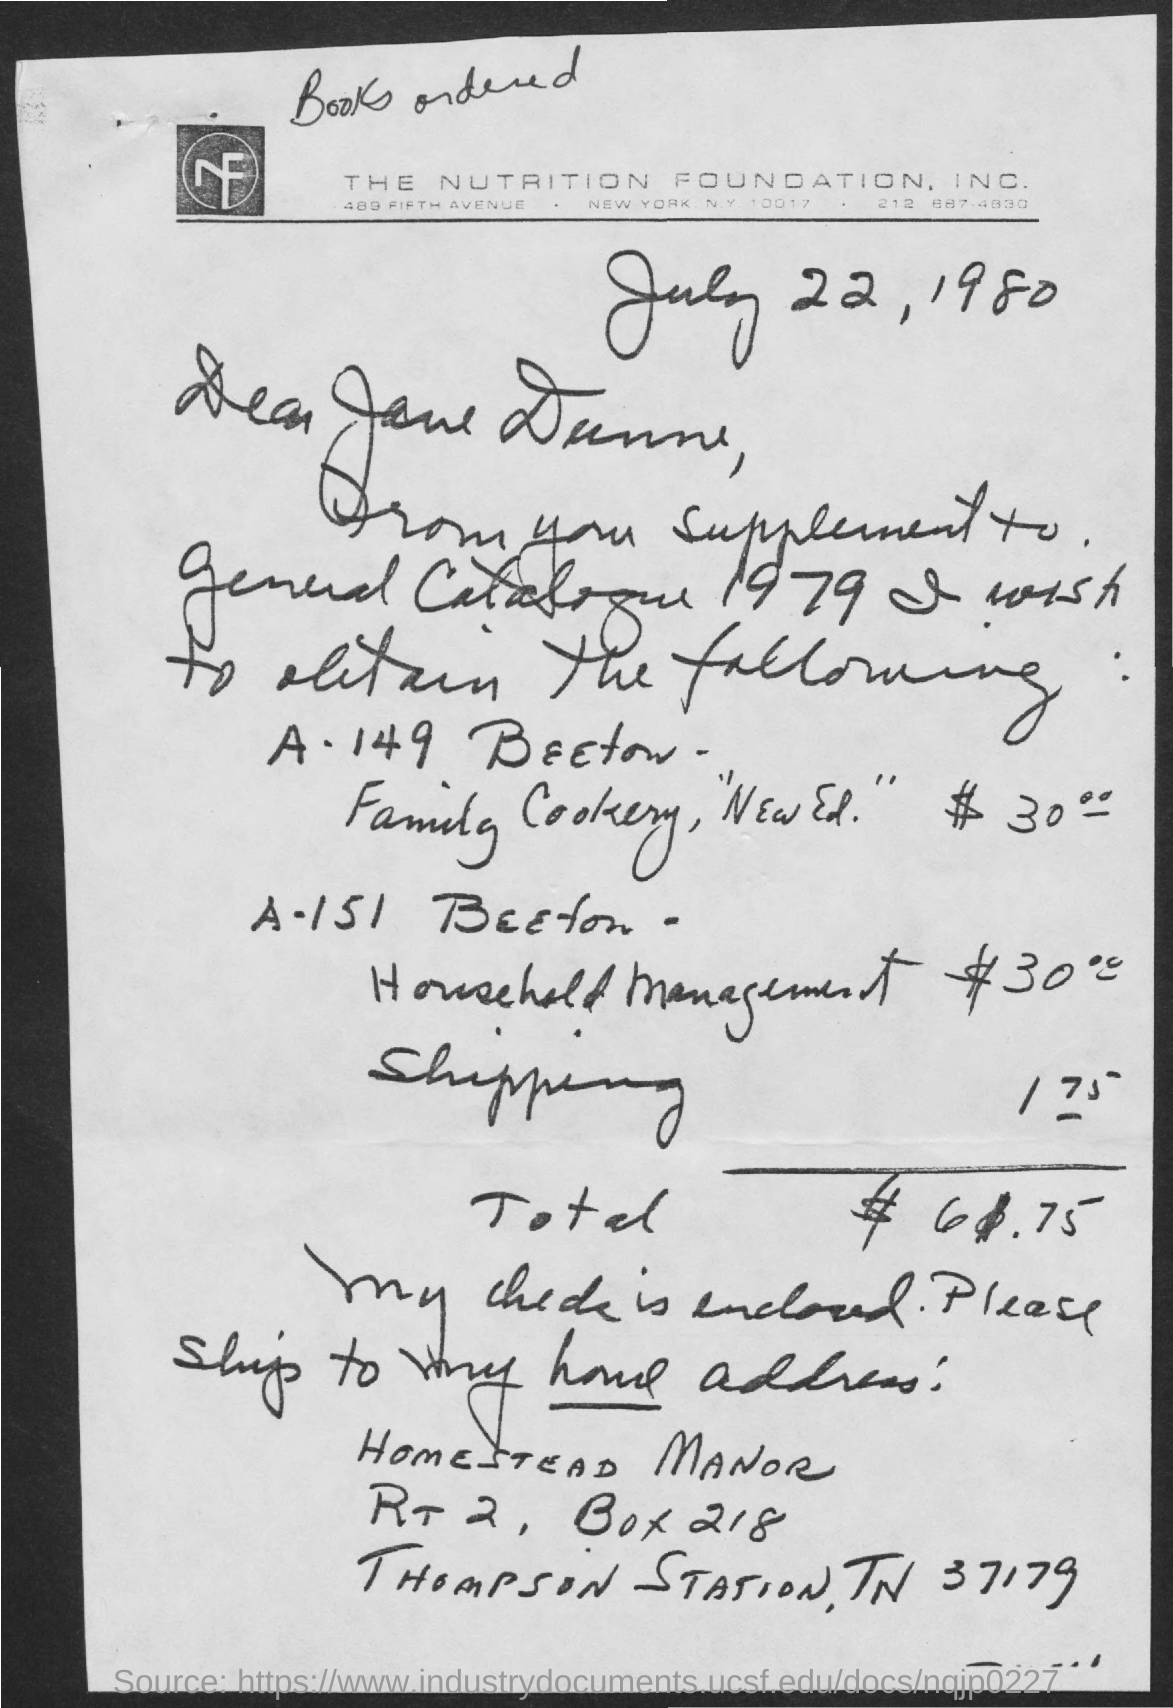Mention a couple of crucial points in this snapshot. The total amount mentioned in the letter is $61.75. The Nutrition Foundation, Inc. is the company mentioned in the letter head. 